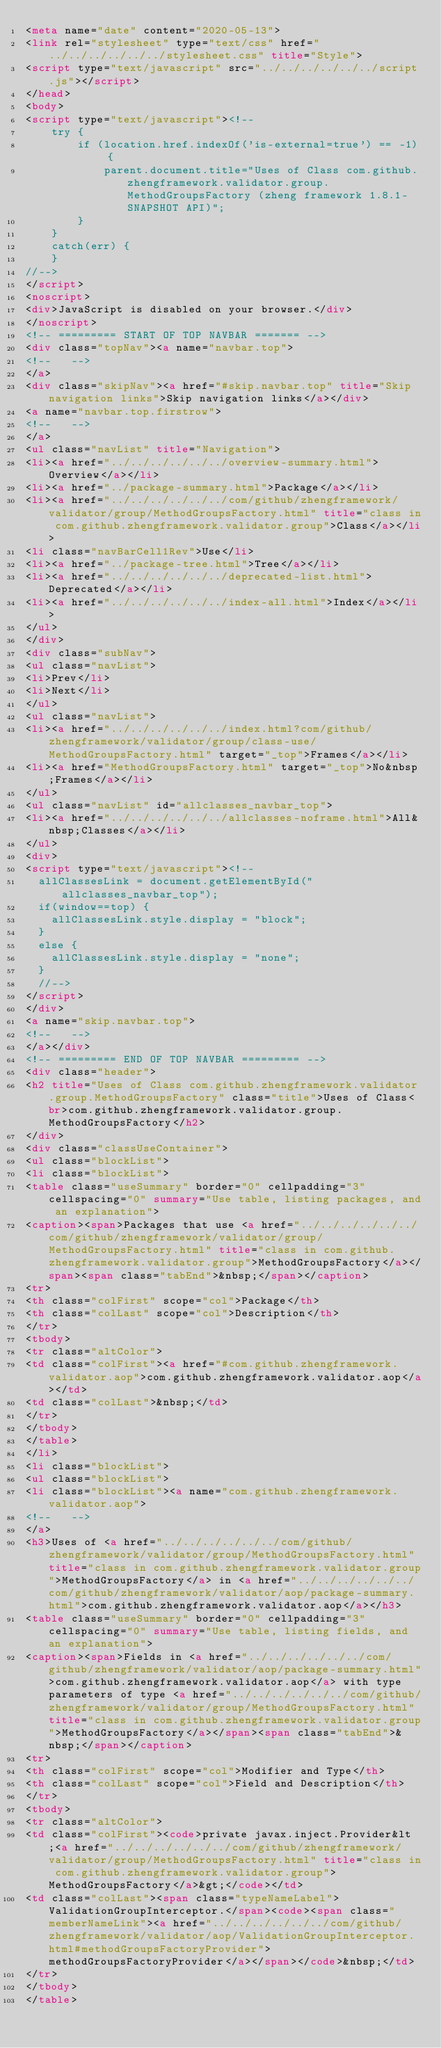<code> <loc_0><loc_0><loc_500><loc_500><_HTML_><meta name="date" content="2020-05-13">
<link rel="stylesheet" type="text/css" href="../../../../../../stylesheet.css" title="Style">
<script type="text/javascript" src="../../../../../../script.js"></script>
</head>
<body>
<script type="text/javascript"><!--
    try {
        if (location.href.indexOf('is-external=true') == -1) {
            parent.document.title="Uses of Class com.github.zhengframework.validator.group.MethodGroupsFactory (zheng framework 1.8.1-SNAPSHOT API)";
        }
    }
    catch(err) {
    }
//-->
</script>
<noscript>
<div>JavaScript is disabled on your browser.</div>
</noscript>
<!-- ========= START OF TOP NAVBAR ======= -->
<div class="topNav"><a name="navbar.top">
<!--   -->
</a>
<div class="skipNav"><a href="#skip.navbar.top" title="Skip navigation links">Skip navigation links</a></div>
<a name="navbar.top.firstrow">
<!--   -->
</a>
<ul class="navList" title="Navigation">
<li><a href="../../../../../../overview-summary.html">Overview</a></li>
<li><a href="../package-summary.html">Package</a></li>
<li><a href="../../../../../../com/github/zhengframework/validator/group/MethodGroupsFactory.html" title="class in com.github.zhengframework.validator.group">Class</a></li>
<li class="navBarCell1Rev">Use</li>
<li><a href="../package-tree.html">Tree</a></li>
<li><a href="../../../../../../deprecated-list.html">Deprecated</a></li>
<li><a href="../../../../../../index-all.html">Index</a></li>
</ul>
</div>
<div class="subNav">
<ul class="navList">
<li>Prev</li>
<li>Next</li>
</ul>
<ul class="navList">
<li><a href="../../../../../../index.html?com/github/zhengframework/validator/group/class-use/MethodGroupsFactory.html" target="_top">Frames</a></li>
<li><a href="MethodGroupsFactory.html" target="_top">No&nbsp;Frames</a></li>
</ul>
<ul class="navList" id="allclasses_navbar_top">
<li><a href="../../../../../../allclasses-noframe.html">All&nbsp;Classes</a></li>
</ul>
<div>
<script type="text/javascript"><!--
  allClassesLink = document.getElementById("allclasses_navbar_top");
  if(window==top) {
    allClassesLink.style.display = "block";
  }
  else {
    allClassesLink.style.display = "none";
  }
  //-->
</script>
</div>
<a name="skip.navbar.top">
<!--   -->
</a></div>
<!-- ========= END OF TOP NAVBAR ========= -->
<div class="header">
<h2 title="Uses of Class com.github.zhengframework.validator.group.MethodGroupsFactory" class="title">Uses of Class<br>com.github.zhengframework.validator.group.MethodGroupsFactory</h2>
</div>
<div class="classUseContainer">
<ul class="blockList">
<li class="blockList">
<table class="useSummary" border="0" cellpadding="3" cellspacing="0" summary="Use table, listing packages, and an explanation">
<caption><span>Packages that use <a href="../../../../../../com/github/zhengframework/validator/group/MethodGroupsFactory.html" title="class in com.github.zhengframework.validator.group">MethodGroupsFactory</a></span><span class="tabEnd">&nbsp;</span></caption>
<tr>
<th class="colFirst" scope="col">Package</th>
<th class="colLast" scope="col">Description</th>
</tr>
<tbody>
<tr class="altColor">
<td class="colFirst"><a href="#com.github.zhengframework.validator.aop">com.github.zhengframework.validator.aop</a></td>
<td class="colLast">&nbsp;</td>
</tr>
</tbody>
</table>
</li>
<li class="blockList">
<ul class="blockList">
<li class="blockList"><a name="com.github.zhengframework.validator.aop">
<!--   -->
</a>
<h3>Uses of <a href="../../../../../../com/github/zhengframework/validator/group/MethodGroupsFactory.html" title="class in com.github.zhengframework.validator.group">MethodGroupsFactory</a> in <a href="../../../../../../com/github/zhengframework/validator/aop/package-summary.html">com.github.zhengframework.validator.aop</a></h3>
<table class="useSummary" border="0" cellpadding="3" cellspacing="0" summary="Use table, listing fields, and an explanation">
<caption><span>Fields in <a href="../../../../../../com/github/zhengframework/validator/aop/package-summary.html">com.github.zhengframework.validator.aop</a> with type parameters of type <a href="../../../../../../com/github/zhengframework/validator/group/MethodGroupsFactory.html" title="class in com.github.zhengframework.validator.group">MethodGroupsFactory</a></span><span class="tabEnd">&nbsp;</span></caption>
<tr>
<th class="colFirst" scope="col">Modifier and Type</th>
<th class="colLast" scope="col">Field and Description</th>
</tr>
<tbody>
<tr class="altColor">
<td class="colFirst"><code>private javax.inject.Provider&lt;<a href="../../../../../../com/github/zhengframework/validator/group/MethodGroupsFactory.html" title="class in com.github.zhengframework.validator.group">MethodGroupsFactory</a>&gt;</code></td>
<td class="colLast"><span class="typeNameLabel">ValidationGroupInterceptor.</span><code><span class="memberNameLink"><a href="../../../../../../com/github/zhengframework/validator/aop/ValidationGroupInterceptor.html#methodGroupsFactoryProvider">methodGroupsFactoryProvider</a></span></code>&nbsp;</td>
</tr>
</tbody>
</table></code> 